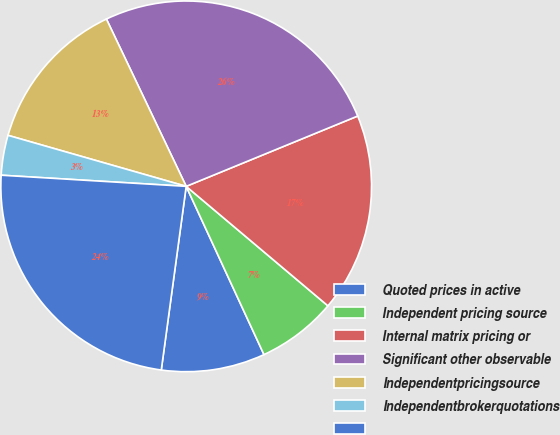<chart> <loc_0><loc_0><loc_500><loc_500><pie_chart><fcel>Quoted prices in active<fcel>Independent pricing source<fcel>Internal matrix pricing or<fcel>Significant other observable<fcel>Independentpricingsource<fcel>Independentbrokerquotations<fcel>Unnamed: 6<nl><fcel>9.04%<fcel>6.96%<fcel>17.34%<fcel>25.89%<fcel>13.48%<fcel>3.48%<fcel>23.81%<nl></chart> 